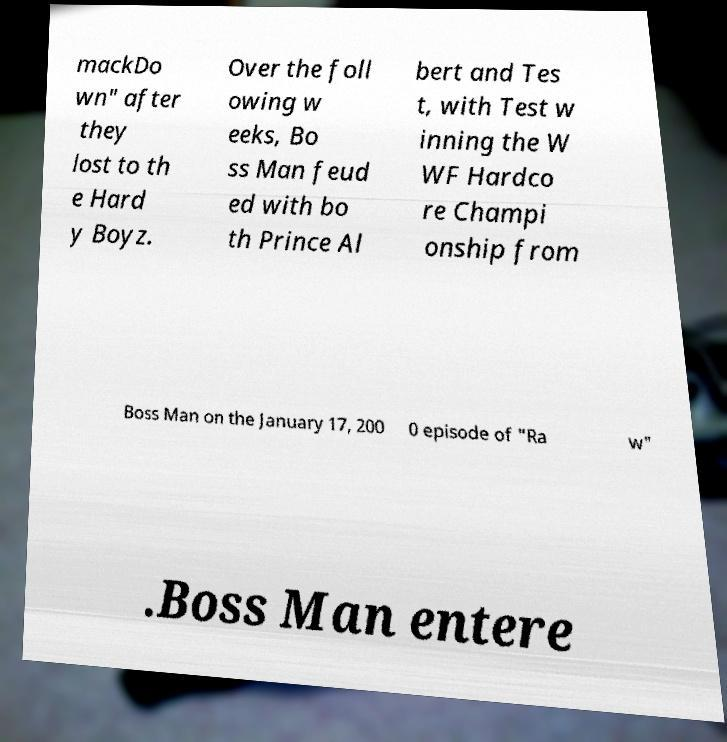Please identify and transcribe the text found in this image. mackDo wn" after they lost to th e Hard y Boyz. Over the foll owing w eeks, Bo ss Man feud ed with bo th Prince Al bert and Tes t, with Test w inning the W WF Hardco re Champi onship from Boss Man on the January 17, 200 0 episode of "Ra w" .Boss Man entere 